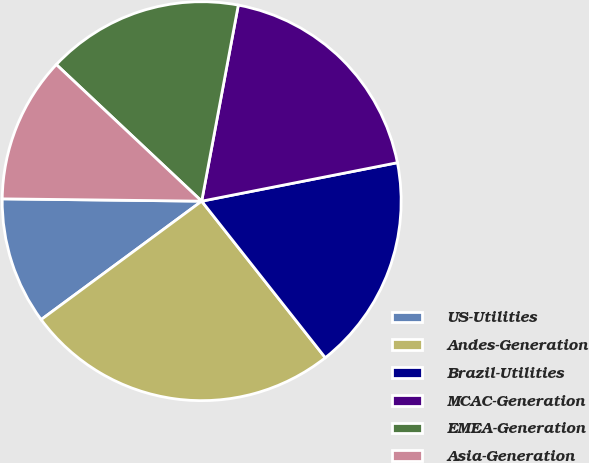Convert chart to OTSL. <chart><loc_0><loc_0><loc_500><loc_500><pie_chart><fcel>US-Utilities<fcel>Andes-Generation<fcel>Brazil-Utilities<fcel>MCAC-Generation<fcel>EMEA-Generation<fcel>Asia-Generation<nl><fcel>10.3%<fcel>25.52%<fcel>17.45%<fcel>18.97%<fcel>15.93%<fcel>11.82%<nl></chart> 